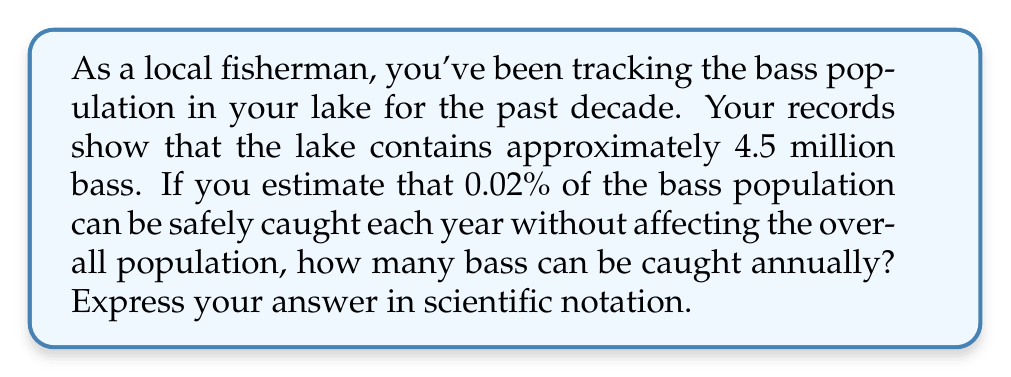Provide a solution to this math problem. To solve this problem, we'll follow these steps:

1. Convert the bass population to scientific notation:
   $4.5 \text{ million} = 4.5 \times 10^6$

2. Calculate 0.02% of the population:
   $0.02\% = 0.0002$ (as a decimal)

3. Multiply the total population by 0.0002:
   $$(4.5 \times 10^6) \times 0.0002$$

4. Simplify:
   $$4.5 \times 10^6 \times 2 \times 10^{-4}$$
   $$= (4.5 \times 2) \times (10^6 \times 10^{-4})$$
   $$= 9 \times 10^2$$

5. The result is already in scientific notation, so no further adjustment is needed.
Answer: $9 \times 10^2$ 